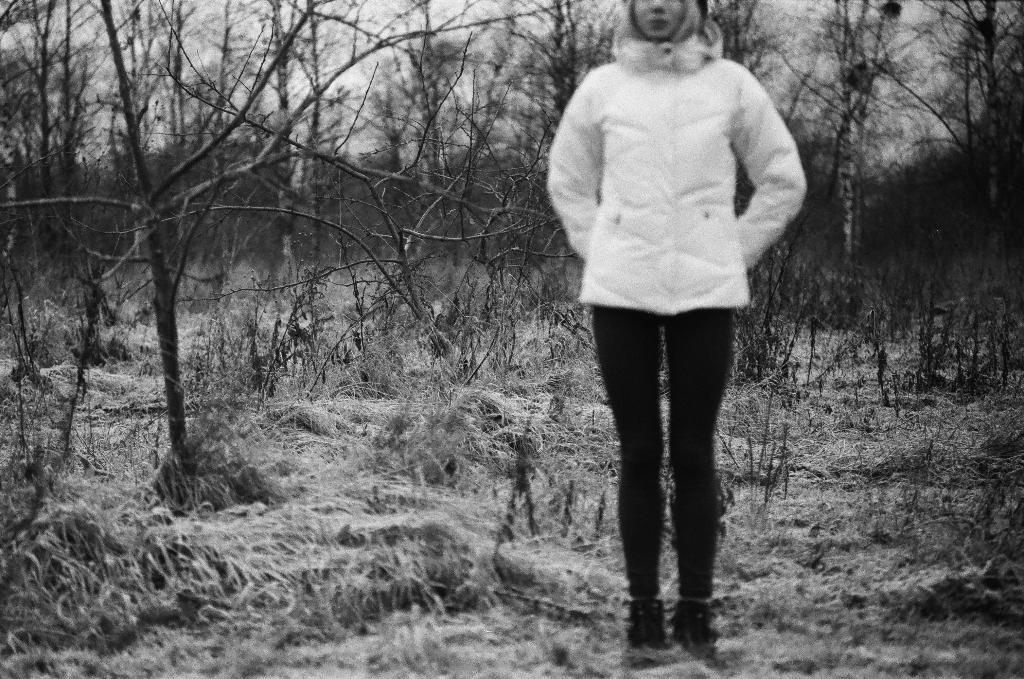What is the main subject of the image? There is a woman standing in the image. What is the woman standing on? The woman is standing on grass. What can be seen in the background of the image? There is sky, dried trees, and plants visible in the background of the image. What is the woman's role as a representative in the image? There is no indication in the image that the woman is a representative, so it cannot be determined from the picture. 